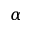Convert formula to latex. <formula><loc_0><loc_0><loc_500><loc_500>\alpha</formula> 